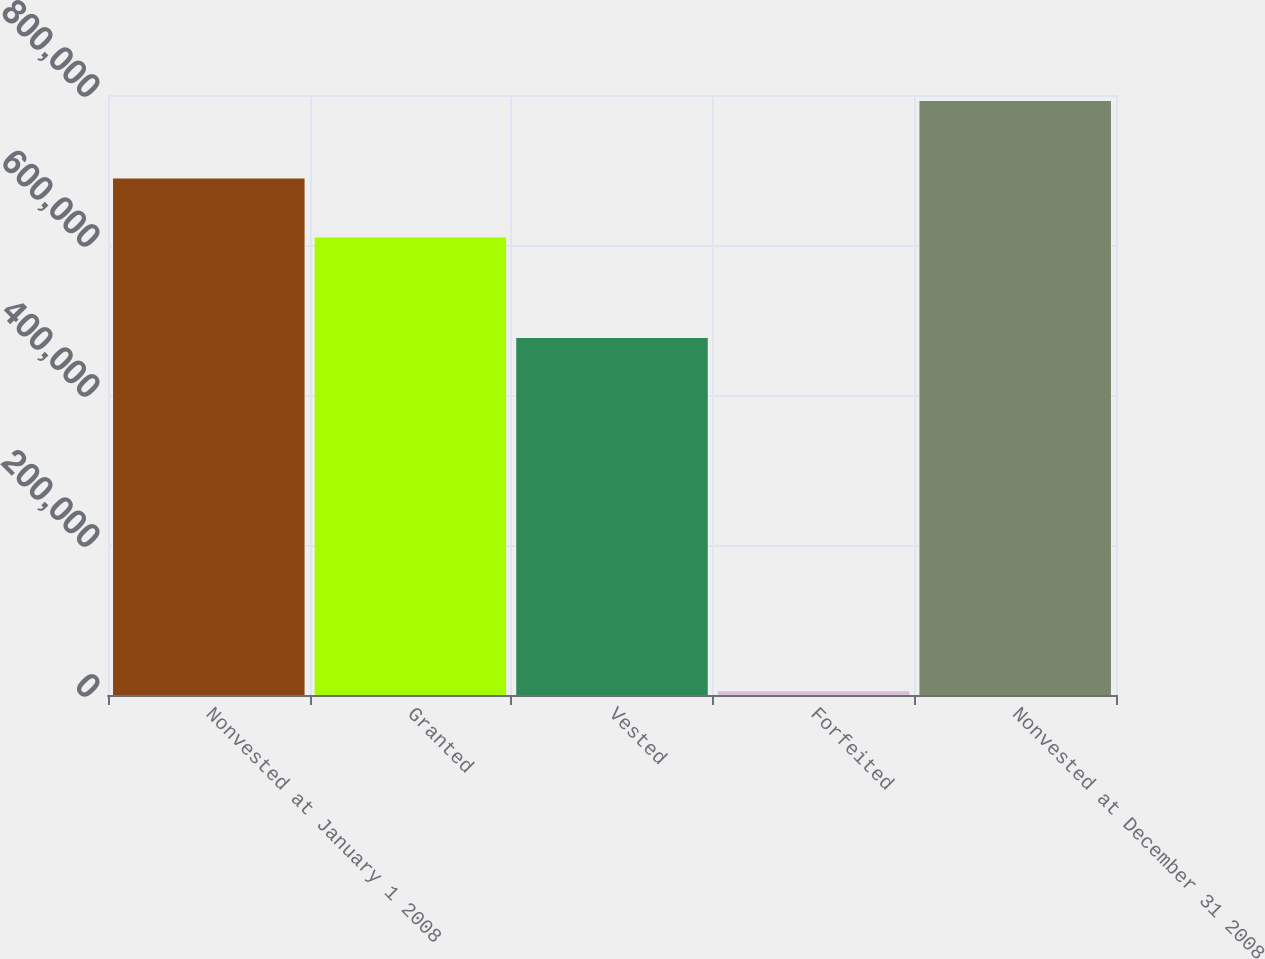Convert chart. <chart><loc_0><loc_0><loc_500><loc_500><bar_chart><fcel>Nonvested at January 1 2008<fcel>Granted<fcel>Vested<fcel>Forfeited<fcel>Nonvested at December 31 2008<nl><fcel>688700<fcel>610000<fcel>476000<fcel>5000<fcel>792000<nl></chart> 